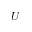<formula> <loc_0><loc_0><loc_500><loc_500>U</formula> 